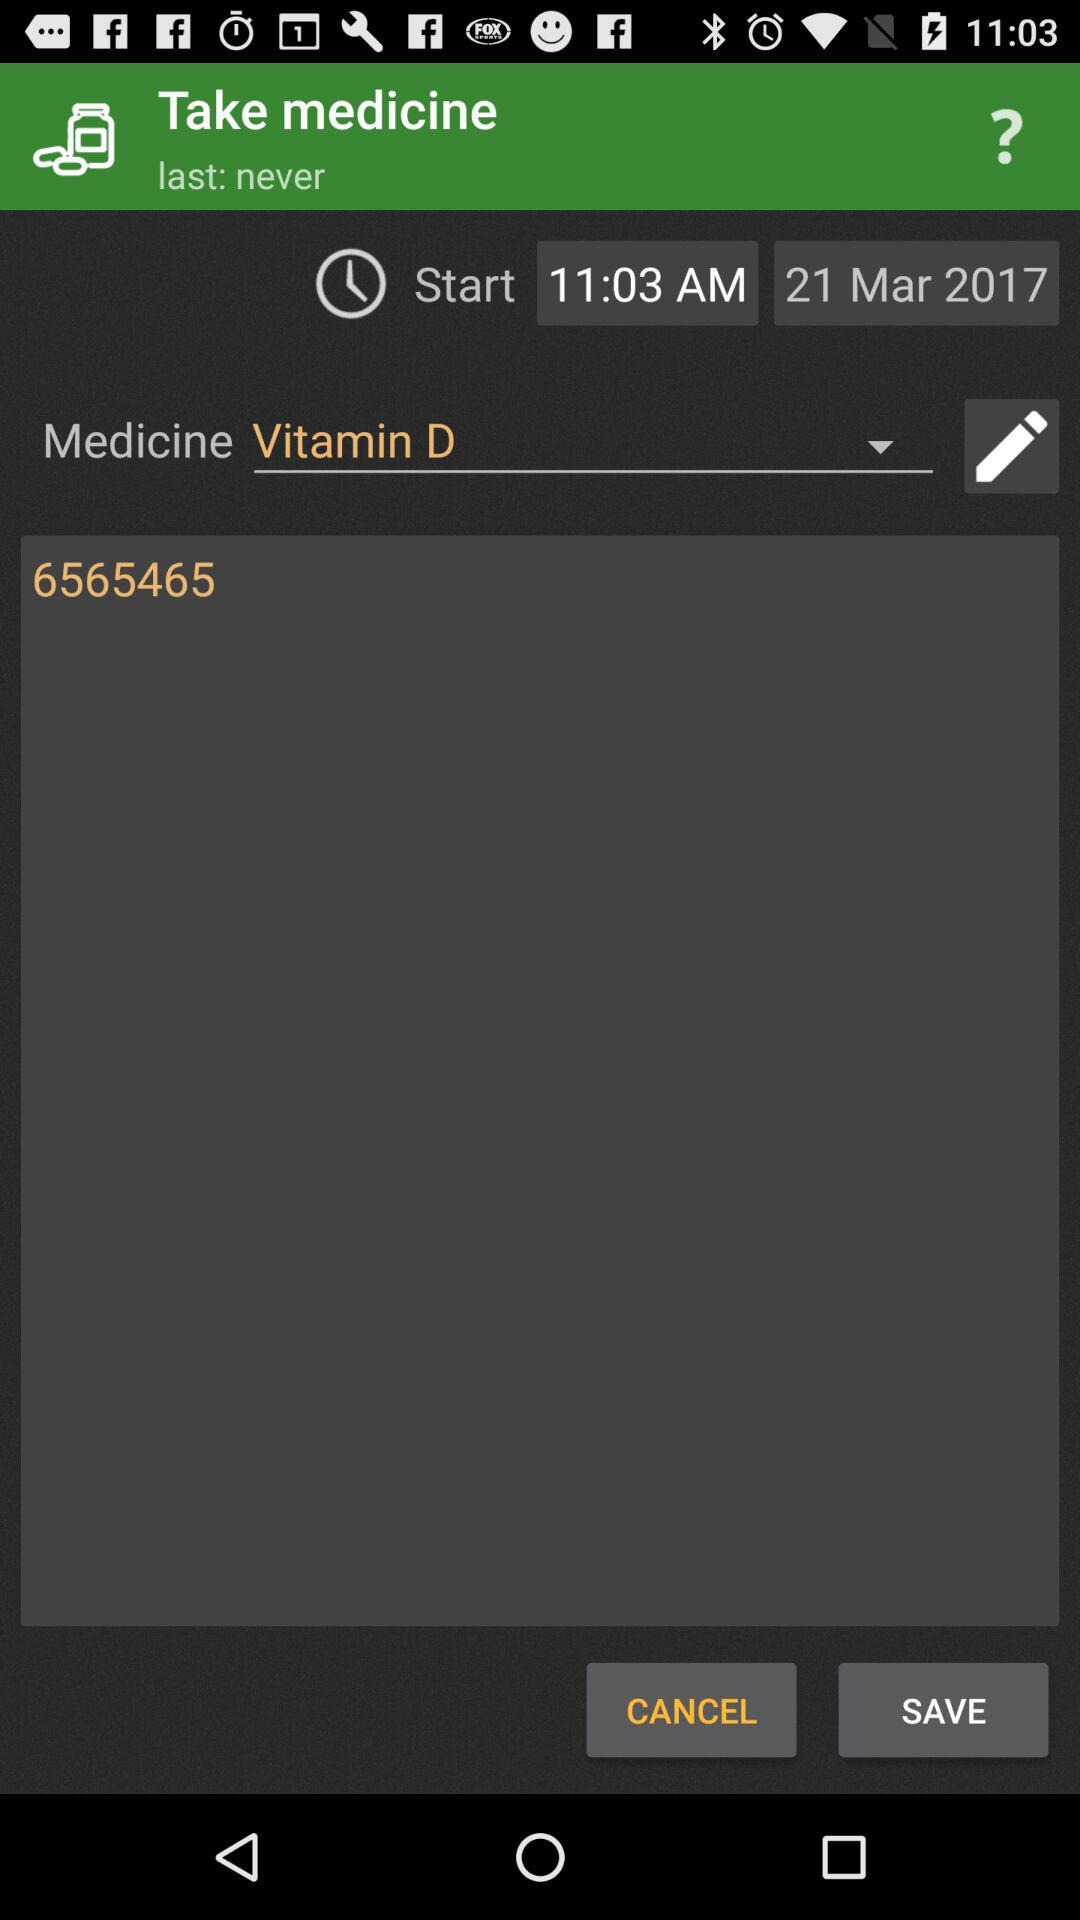What is the last date for taking the medicine?
When the provided information is insufficient, respond with <no answer>. <no answer> 